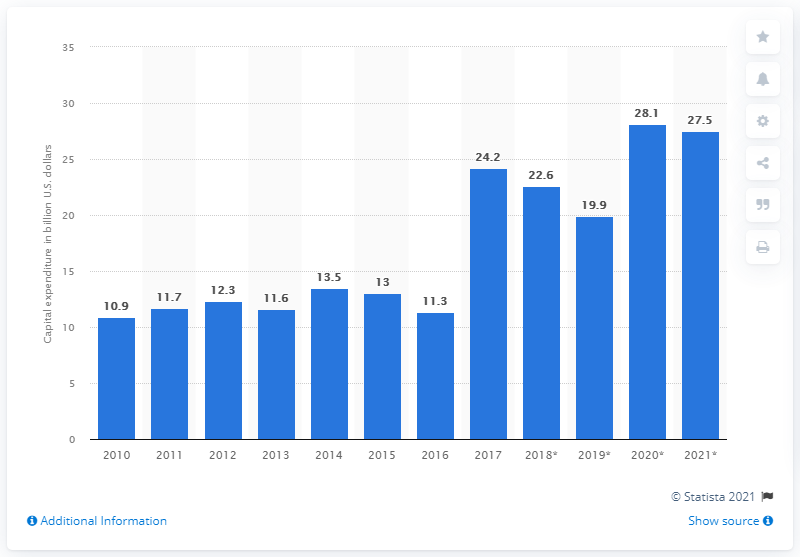Indicate a few pertinent items in this graphic. In 2021, Samsung's semiconductor capital expenditure is expected to reach approximately 27.5 billion U.S. dollars. 